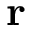<formula> <loc_0><loc_0><loc_500><loc_500>r</formula> 